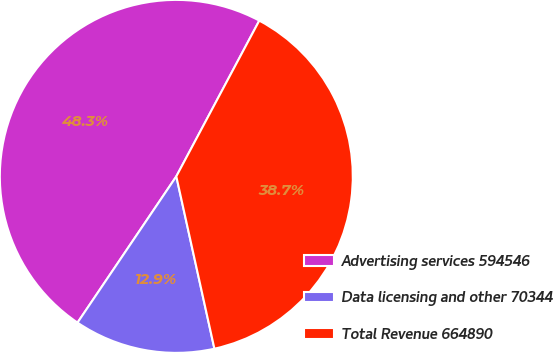Convert chart. <chart><loc_0><loc_0><loc_500><loc_500><pie_chart><fcel>Advertising services 594546<fcel>Data licensing and other 70344<fcel>Total Revenue 664890<nl><fcel>48.34%<fcel>12.92%<fcel>38.75%<nl></chart> 